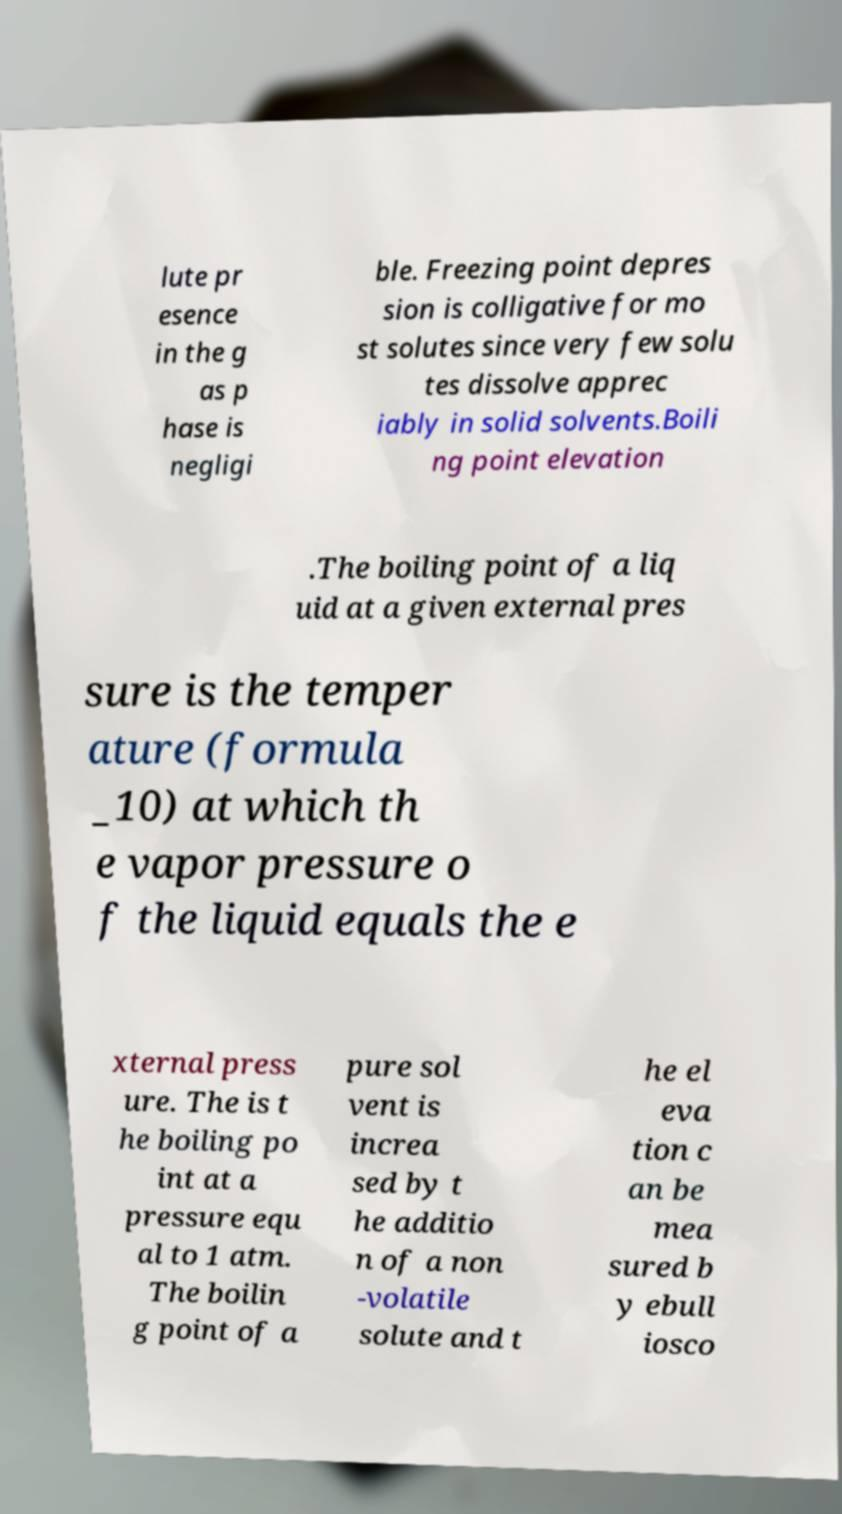What messages or text are displayed in this image? I need them in a readable, typed format. lute pr esence in the g as p hase is negligi ble. Freezing point depres sion is colligative for mo st solutes since very few solu tes dissolve apprec iably in solid solvents.Boili ng point elevation .The boiling point of a liq uid at a given external pres sure is the temper ature (formula _10) at which th e vapor pressure o f the liquid equals the e xternal press ure. The is t he boiling po int at a pressure equ al to 1 atm. The boilin g point of a pure sol vent is increa sed by t he additio n of a non -volatile solute and t he el eva tion c an be mea sured b y ebull iosco 